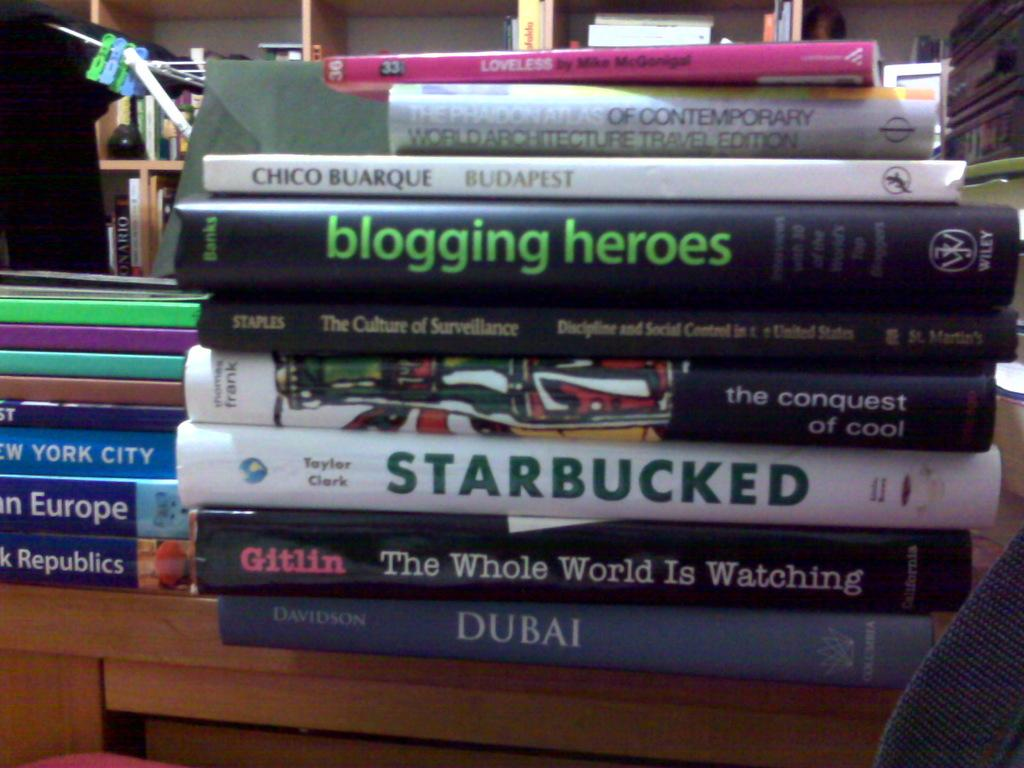<image>
Relay a brief, clear account of the picture shown. A stack of books with one being titled Starbucked. 